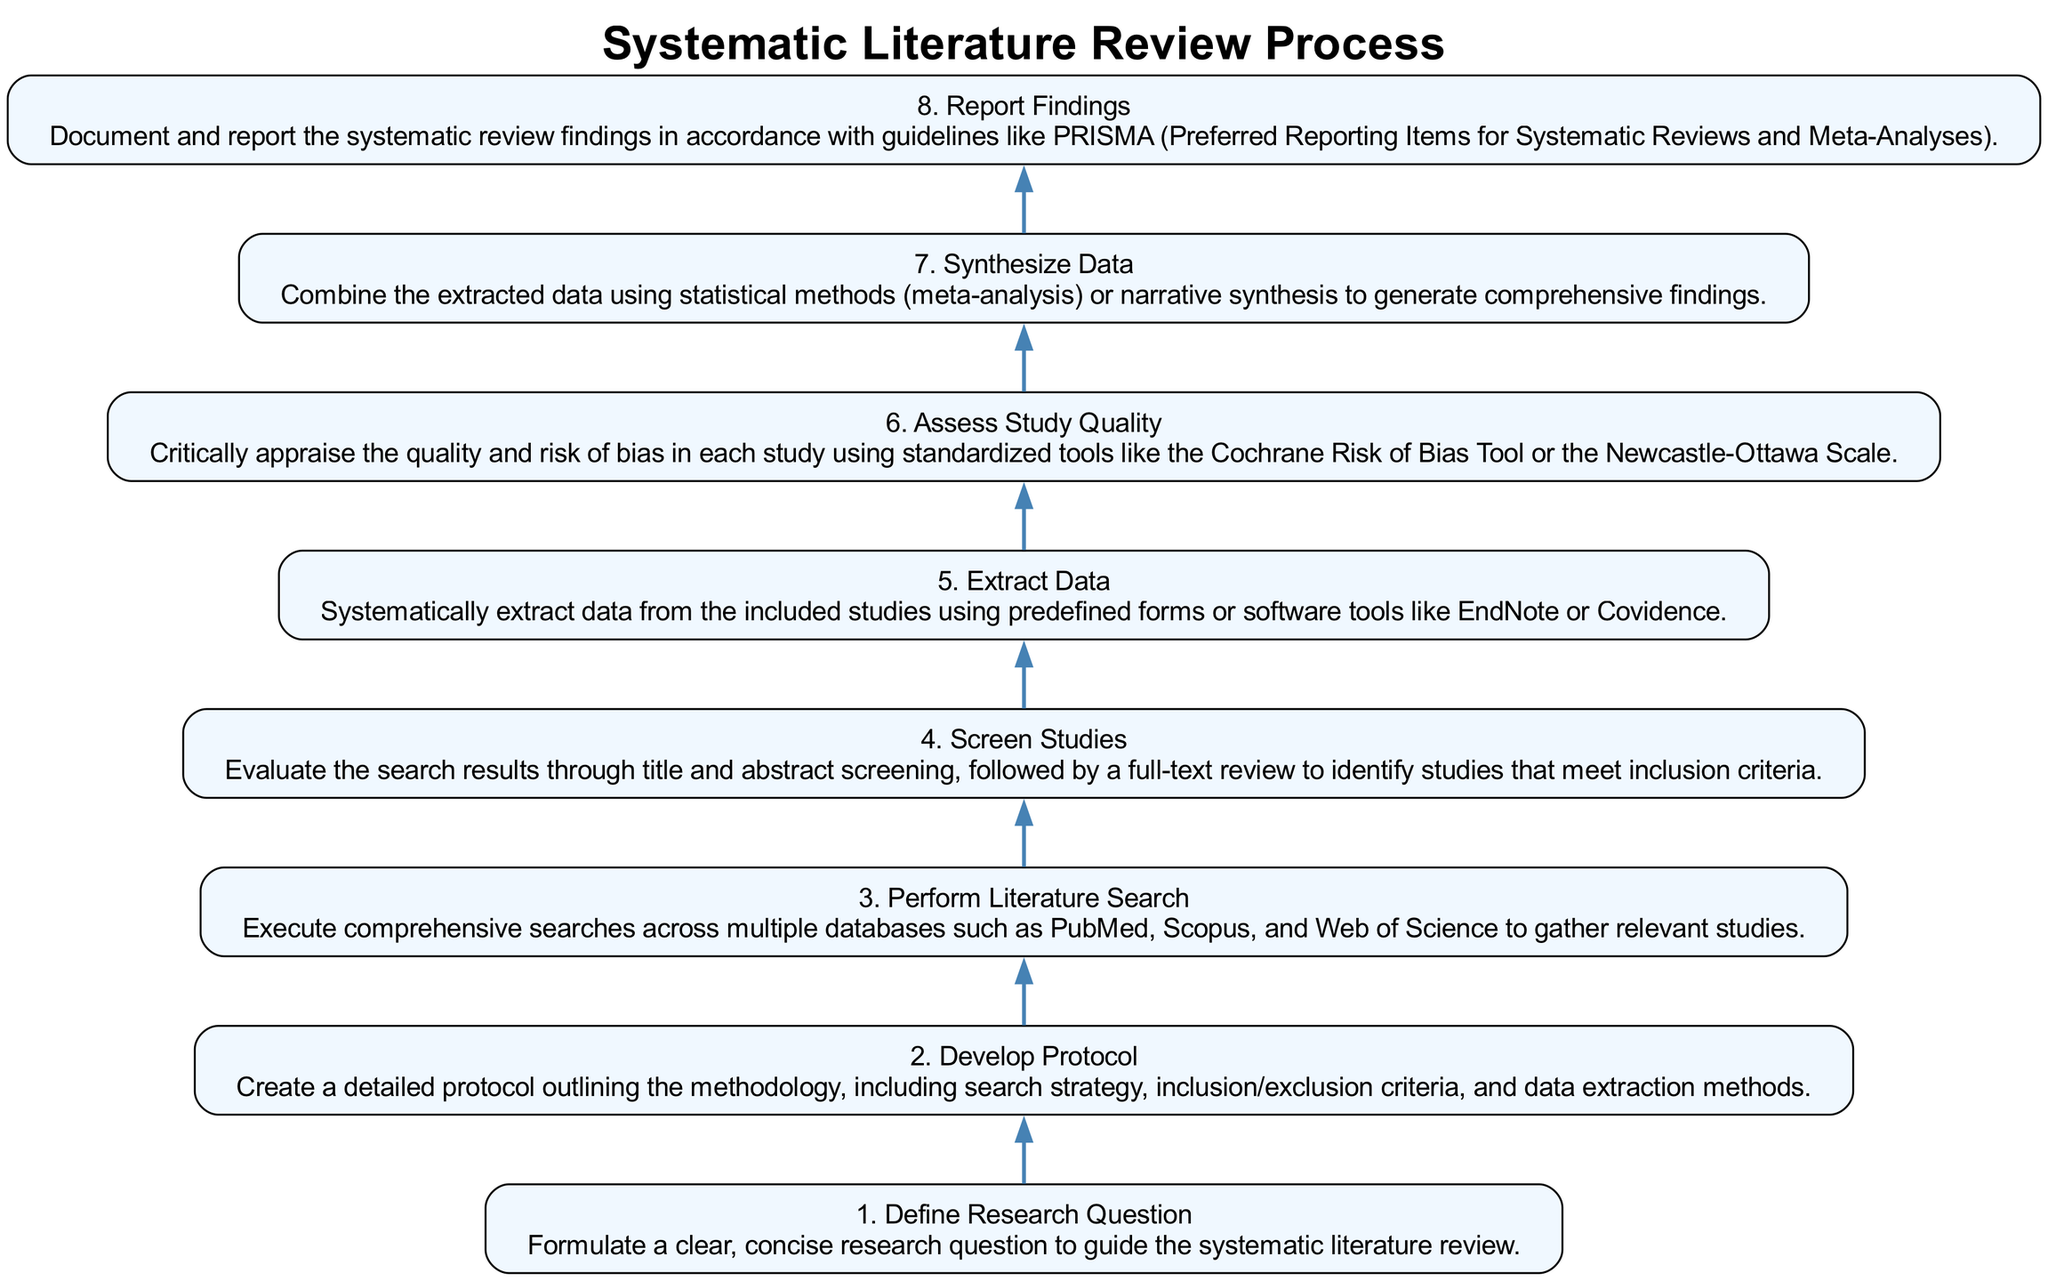What is the first step in the systematic literature review process? The first step is indicated at the bottom of the flow chart and is labeled "Define Research Question," which outlines the necessity of formulating a clear, concise research question.
Answer: Define Research Question How many total steps are in the diagram? By counting each step from the bottom of the flow chart to the top, it's evident there are 8 distinct steps.
Answer: 8 What is the step immediately following "Screen Studies"? The diagram shows that right above "Screen Studies," the next step is "Extract Data." This indicates that data extraction follows the screening process.
Answer: Extract Data Which standardized tools are mentioned for assessing study quality? Looking through the corresponding step in the flow chart, the tools highlighted for assessing study quality include the Cochrane Risk of Bias Tool and the Newcastle-Ottawa Scale.
Answer: Cochrane Risk of Bias Tool and Newcastle-Ottawa Scale What is the last step in conducting a systematic literature review? The last step at the top of the flow chart is labeled "Report Findings," indicating that after synthesizing the data, the final process is to document and report the findings.
Answer: Report Findings What is the relationship between "Develop Protocol" and "Perform Literature Search"? "Develop Protocol" is the second step, and "Perform Literature Search" is the third; this shows a direct sequential relationship where developing a protocol precedes executing a literature search.
Answer: Sequential relationship How does “Synthesize Data” relate to “Extract Data”? "Extract Data" is step five, and "Synthesize Data" is step seven; this indicates that data extraction is a prerequisite process before synthesizing the data, showing a direct dependency in the workflow.
Answer: Data extraction precedes synthesis What methodology aspect is included in the protocol development? The flow chart specifies that the protocol includes the search strategy, inclusion/exclusion criteria, and data extraction methods, clarifying the elements involved in developing the protocol.
Answer: Search strategy, inclusion/exclusion criteria, data extraction methods 